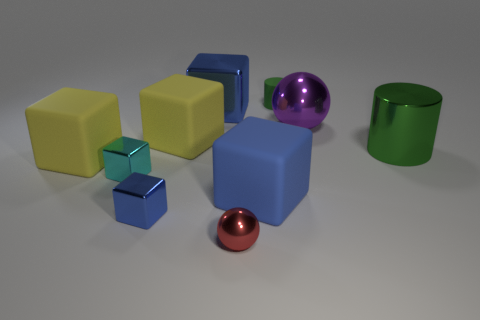Which object stands out the most to you and why? The purple rubber sphere stands out the most due to its distinct color, which contrasts with the other colors present, and its shiny reflective surface which catches the light differently than the other objects. 